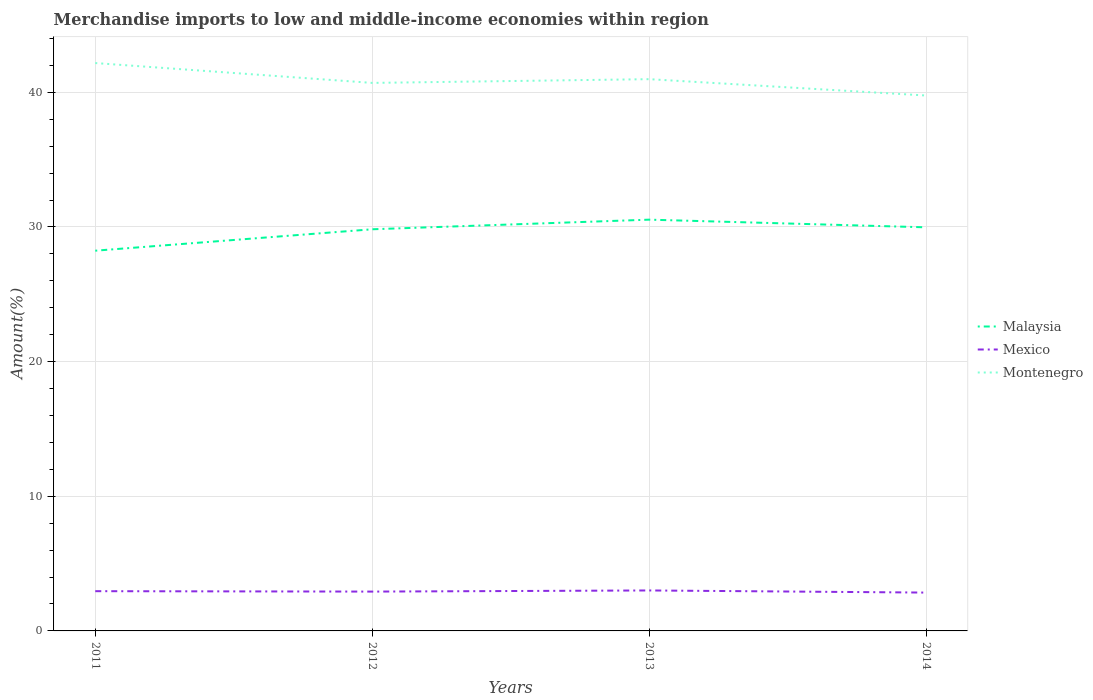Is the number of lines equal to the number of legend labels?
Your answer should be compact. Yes. Across all years, what is the maximum percentage of amount earned from merchandise imports in Malaysia?
Provide a short and direct response. 28.24. In which year was the percentage of amount earned from merchandise imports in Malaysia maximum?
Your response must be concise. 2011. What is the total percentage of amount earned from merchandise imports in Montenegro in the graph?
Your answer should be compact. 1.2. What is the difference between the highest and the second highest percentage of amount earned from merchandise imports in Malaysia?
Ensure brevity in your answer.  2.3. How many years are there in the graph?
Give a very brief answer. 4. What is the difference between two consecutive major ticks on the Y-axis?
Your answer should be compact. 10. Does the graph contain grids?
Your answer should be compact. Yes. Where does the legend appear in the graph?
Keep it short and to the point. Center right. How many legend labels are there?
Provide a succinct answer. 3. How are the legend labels stacked?
Make the answer very short. Vertical. What is the title of the graph?
Keep it short and to the point. Merchandise imports to low and middle-income economies within region. What is the label or title of the X-axis?
Provide a succinct answer. Years. What is the label or title of the Y-axis?
Your answer should be very brief. Amount(%). What is the Amount(%) of Malaysia in 2011?
Ensure brevity in your answer.  28.24. What is the Amount(%) in Mexico in 2011?
Provide a short and direct response. 2.95. What is the Amount(%) of Montenegro in 2011?
Provide a succinct answer. 42.17. What is the Amount(%) in Malaysia in 2012?
Provide a short and direct response. 29.83. What is the Amount(%) in Mexico in 2012?
Your response must be concise. 2.92. What is the Amount(%) in Montenegro in 2012?
Your response must be concise. 40.7. What is the Amount(%) of Malaysia in 2013?
Give a very brief answer. 30.54. What is the Amount(%) in Mexico in 2013?
Make the answer very short. 3.01. What is the Amount(%) of Montenegro in 2013?
Provide a short and direct response. 40.98. What is the Amount(%) in Malaysia in 2014?
Provide a short and direct response. 29.97. What is the Amount(%) in Mexico in 2014?
Ensure brevity in your answer.  2.85. What is the Amount(%) of Montenegro in 2014?
Offer a very short reply. 39.76. Across all years, what is the maximum Amount(%) of Malaysia?
Your response must be concise. 30.54. Across all years, what is the maximum Amount(%) of Mexico?
Your answer should be very brief. 3.01. Across all years, what is the maximum Amount(%) of Montenegro?
Your answer should be compact. 42.17. Across all years, what is the minimum Amount(%) of Malaysia?
Your answer should be compact. 28.24. Across all years, what is the minimum Amount(%) of Mexico?
Provide a succinct answer. 2.85. Across all years, what is the minimum Amount(%) of Montenegro?
Provide a succinct answer. 39.76. What is the total Amount(%) in Malaysia in the graph?
Provide a succinct answer. 118.58. What is the total Amount(%) in Mexico in the graph?
Your response must be concise. 11.72. What is the total Amount(%) in Montenegro in the graph?
Ensure brevity in your answer.  163.61. What is the difference between the Amount(%) of Malaysia in 2011 and that in 2012?
Offer a very short reply. -1.59. What is the difference between the Amount(%) in Mexico in 2011 and that in 2012?
Give a very brief answer. 0.03. What is the difference between the Amount(%) of Montenegro in 2011 and that in 2012?
Your answer should be very brief. 1.47. What is the difference between the Amount(%) of Malaysia in 2011 and that in 2013?
Your response must be concise. -2.3. What is the difference between the Amount(%) of Mexico in 2011 and that in 2013?
Offer a terse response. -0.05. What is the difference between the Amount(%) of Montenegro in 2011 and that in 2013?
Ensure brevity in your answer.  1.2. What is the difference between the Amount(%) of Malaysia in 2011 and that in 2014?
Offer a very short reply. -1.74. What is the difference between the Amount(%) in Mexico in 2011 and that in 2014?
Offer a terse response. 0.1. What is the difference between the Amount(%) in Montenegro in 2011 and that in 2014?
Keep it short and to the point. 2.41. What is the difference between the Amount(%) in Malaysia in 2012 and that in 2013?
Keep it short and to the point. -0.71. What is the difference between the Amount(%) of Mexico in 2012 and that in 2013?
Offer a very short reply. -0.08. What is the difference between the Amount(%) in Montenegro in 2012 and that in 2013?
Give a very brief answer. -0.28. What is the difference between the Amount(%) in Malaysia in 2012 and that in 2014?
Your answer should be very brief. -0.14. What is the difference between the Amount(%) of Mexico in 2012 and that in 2014?
Offer a terse response. 0.07. What is the difference between the Amount(%) of Montenegro in 2012 and that in 2014?
Make the answer very short. 0.94. What is the difference between the Amount(%) in Malaysia in 2013 and that in 2014?
Your answer should be very brief. 0.57. What is the difference between the Amount(%) in Mexico in 2013 and that in 2014?
Provide a succinct answer. 0.16. What is the difference between the Amount(%) in Montenegro in 2013 and that in 2014?
Make the answer very short. 1.21. What is the difference between the Amount(%) in Malaysia in 2011 and the Amount(%) in Mexico in 2012?
Give a very brief answer. 25.32. What is the difference between the Amount(%) in Malaysia in 2011 and the Amount(%) in Montenegro in 2012?
Offer a terse response. -12.46. What is the difference between the Amount(%) of Mexico in 2011 and the Amount(%) of Montenegro in 2012?
Offer a very short reply. -37.75. What is the difference between the Amount(%) of Malaysia in 2011 and the Amount(%) of Mexico in 2013?
Offer a very short reply. 25.23. What is the difference between the Amount(%) in Malaysia in 2011 and the Amount(%) in Montenegro in 2013?
Ensure brevity in your answer.  -12.74. What is the difference between the Amount(%) of Mexico in 2011 and the Amount(%) of Montenegro in 2013?
Keep it short and to the point. -38.02. What is the difference between the Amount(%) in Malaysia in 2011 and the Amount(%) in Mexico in 2014?
Your response must be concise. 25.39. What is the difference between the Amount(%) in Malaysia in 2011 and the Amount(%) in Montenegro in 2014?
Give a very brief answer. -11.52. What is the difference between the Amount(%) in Mexico in 2011 and the Amount(%) in Montenegro in 2014?
Make the answer very short. -36.81. What is the difference between the Amount(%) of Malaysia in 2012 and the Amount(%) of Mexico in 2013?
Give a very brief answer. 26.82. What is the difference between the Amount(%) of Malaysia in 2012 and the Amount(%) of Montenegro in 2013?
Provide a succinct answer. -11.15. What is the difference between the Amount(%) in Mexico in 2012 and the Amount(%) in Montenegro in 2013?
Keep it short and to the point. -38.06. What is the difference between the Amount(%) of Malaysia in 2012 and the Amount(%) of Mexico in 2014?
Your answer should be very brief. 26.98. What is the difference between the Amount(%) of Malaysia in 2012 and the Amount(%) of Montenegro in 2014?
Provide a succinct answer. -9.93. What is the difference between the Amount(%) in Mexico in 2012 and the Amount(%) in Montenegro in 2014?
Your response must be concise. -36.84. What is the difference between the Amount(%) in Malaysia in 2013 and the Amount(%) in Mexico in 2014?
Offer a very short reply. 27.7. What is the difference between the Amount(%) of Malaysia in 2013 and the Amount(%) of Montenegro in 2014?
Your response must be concise. -9.22. What is the difference between the Amount(%) of Mexico in 2013 and the Amount(%) of Montenegro in 2014?
Your response must be concise. -36.76. What is the average Amount(%) of Malaysia per year?
Offer a very short reply. 29.65. What is the average Amount(%) of Mexico per year?
Keep it short and to the point. 2.93. What is the average Amount(%) in Montenegro per year?
Ensure brevity in your answer.  40.9. In the year 2011, what is the difference between the Amount(%) in Malaysia and Amount(%) in Mexico?
Provide a short and direct response. 25.29. In the year 2011, what is the difference between the Amount(%) in Malaysia and Amount(%) in Montenegro?
Offer a terse response. -13.94. In the year 2011, what is the difference between the Amount(%) in Mexico and Amount(%) in Montenegro?
Provide a succinct answer. -39.22. In the year 2012, what is the difference between the Amount(%) of Malaysia and Amount(%) of Mexico?
Your answer should be compact. 26.91. In the year 2012, what is the difference between the Amount(%) of Malaysia and Amount(%) of Montenegro?
Offer a very short reply. -10.87. In the year 2012, what is the difference between the Amount(%) in Mexico and Amount(%) in Montenegro?
Offer a very short reply. -37.78. In the year 2013, what is the difference between the Amount(%) of Malaysia and Amount(%) of Mexico?
Your answer should be compact. 27.54. In the year 2013, what is the difference between the Amount(%) of Malaysia and Amount(%) of Montenegro?
Your answer should be compact. -10.43. In the year 2013, what is the difference between the Amount(%) of Mexico and Amount(%) of Montenegro?
Your answer should be compact. -37.97. In the year 2014, what is the difference between the Amount(%) of Malaysia and Amount(%) of Mexico?
Make the answer very short. 27.13. In the year 2014, what is the difference between the Amount(%) in Malaysia and Amount(%) in Montenegro?
Offer a very short reply. -9.79. In the year 2014, what is the difference between the Amount(%) of Mexico and Amount(%) of Montenegro?
Your answer should be very brief. -36.91. What is the ratio of the Amount(%) of Malaysia in 2011 to that in 2012?
Your answer should be very brief. 0.95. What is the ratio of the Amount(%) of Mexico in 2011 to that in 2012?
Provide a succinct answer. 1.01. What is the ratio of the Amount(%) in Montenegro in 2011 to that in 2012?
Keep it short and to the point. 1.04. What is the ratio of the Amount(%) in Malaysia in 2011 to that in 2013?
Your response must be concise. 0.92. What is the ratio of the Amount(%) in Mexico in 2011 to that in 2013?
Keep it short and to the point. 0.98. What is the ratio of the Amount(%) in Montenegro in 2011 to that in 2013?
Offer a very short reply. 1.03. What is the ratio of the Amount(%) in Malaysia in 2011 to that in 2014?
Your response must be concise. 0.94. What is the ratio of the Amount(%) of Mexico in 2011 to that in 2014?
Give a very brief answer. 1.04. What is the ratio of the Amount(%) in Montenegro in 2011 to that in 2014?
Give a very brief answer. 1.06. What is the ratio of the Amount(%) of Malaysia in 2012 to that in 2013?
Keep it short and to the point. 0.98. What is the ratio of the Amount(%) of Mexico in 2012 to that in 2013?
Your answer should be compact. 0.97. What is the ratio of the Amount(%) in Montenegro in 2012 to that in 2013?
Your answer should be very brief. 0.99. What is the ratio of the Amount(%) in Mexico in 2012 to that in 2014?
Ensure brevity in your answer.  1.03. What is the ratio of the Amount(%) in Montenegro in 2012 to that in 2014?
Keep it short and to the point. 1.02. What is the ratio of the Amount(%) of Mexico in 2013 to that in 2014?
Keep it short and to the point. 1.06. What is the ratio of the Amount(%) of Montenegro in 2013 to that in 2014?
Make the answer very short. 1.03. What is the difference between the highest and the second highest Amount(%) in Malaysia?
Keep it short and to the point. 0.57. What is the difference between the highest and the second highest Amount(%) in Mexico?
Give a very brief answer. 0.05. What is the difference between the highest and the second highest Amount(%) in Montenegro?
Give a very brief answer. 1.2. What is the difference between the highest and the lowest Amount(%) in Malaysia?
Your answer should be compact. 2.3. What is the difference between the highest and the lowest Amount(%) of Mexico?
Make the answer very short. 0.16. What is the difference between the highest and the lowest Amount(%) in Montenegro?
Make the answer very short. 2.41. 